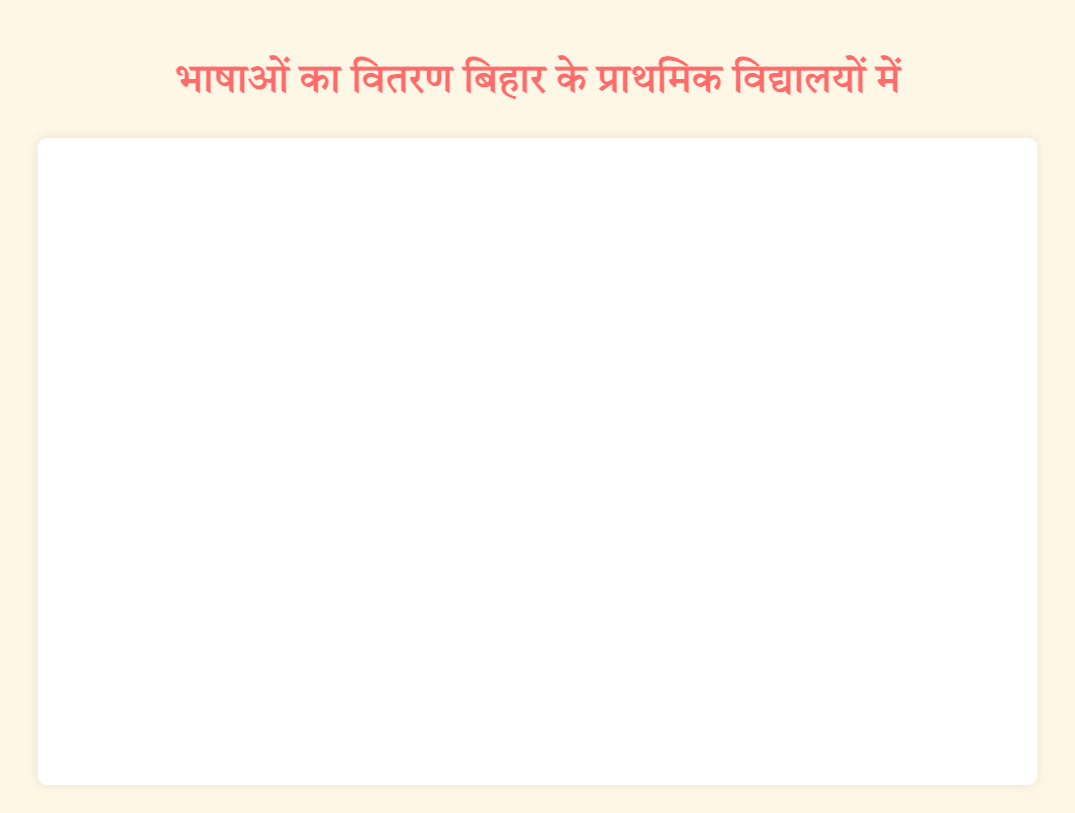What is the title of the figure? The title is usually at the top of the figure and provides an overview of what the chart represents. In this case, it says "भाषाओं का वितरण बिहार के प्राथमिक विद्यालयों में" which translates to "Distribution of Languages in Bihar Primary Schools".
Answer: Distribution of Languages in Bihar Primary Schools Which language has the largest bubble? The size of the bubble represents the number of students. The largest bubble corresponds to the language with the highest number of students, which is "Hindi" with bubbles at 1200 and 1100 students.
Answer: Hindi How many primary schools are represented for the Maithili language? By examining the bubbles, you can see there are two schools: "Bhagalpur Primary School" and "Madhubani Primary School" listed under Maithili.
Answer: 2 What is the total number of students in primary schools who speak Angika? To find the total, add the number of students from “Darbhanga Primary School” and “Begusarai Primary School": 300 + 350.
Answer: 650 Which two schools have the closest number of students speaking different languages? By comparing the number of students, "Muzzafarpur Primary School" with 450 students (Urdu) and "Begusarai Primary School" with 350 students (Angika) have the closest numbers, differing by 100.
Answer: Muzzafarpur Primary School and Begusarai Primary School Among the schools that have Bhojpuri-speaking students, which one has fewer students? By checking the bubbles for Bhojpuri, "Chapra Primary School" has 850 students and "Gaya Primary School" has 900 students.
Answer: Chapra Primary School How many students in total are represented in the figure? Add the number of students for all schools: 1200 (Patna) + 900 (Gaya) + 600 (Bhagalpur) + 450 (Muzzafarpur) + 300 (Darbhanga) + 1100 (Nalanda) + 850 (Chapra) + 700 (Madhubani) + 300 (Arrah) + 350 (Begusarai) = 6750
Answer: 6750 Which language has the smallest bubble and how many students does it represent? The smallest bubbles are those representing Angika, with 300 students at "Darbhanga Primary School" and 350 students at "Begusarai Primary School".
Answer: Angika, 300 and 350 students 